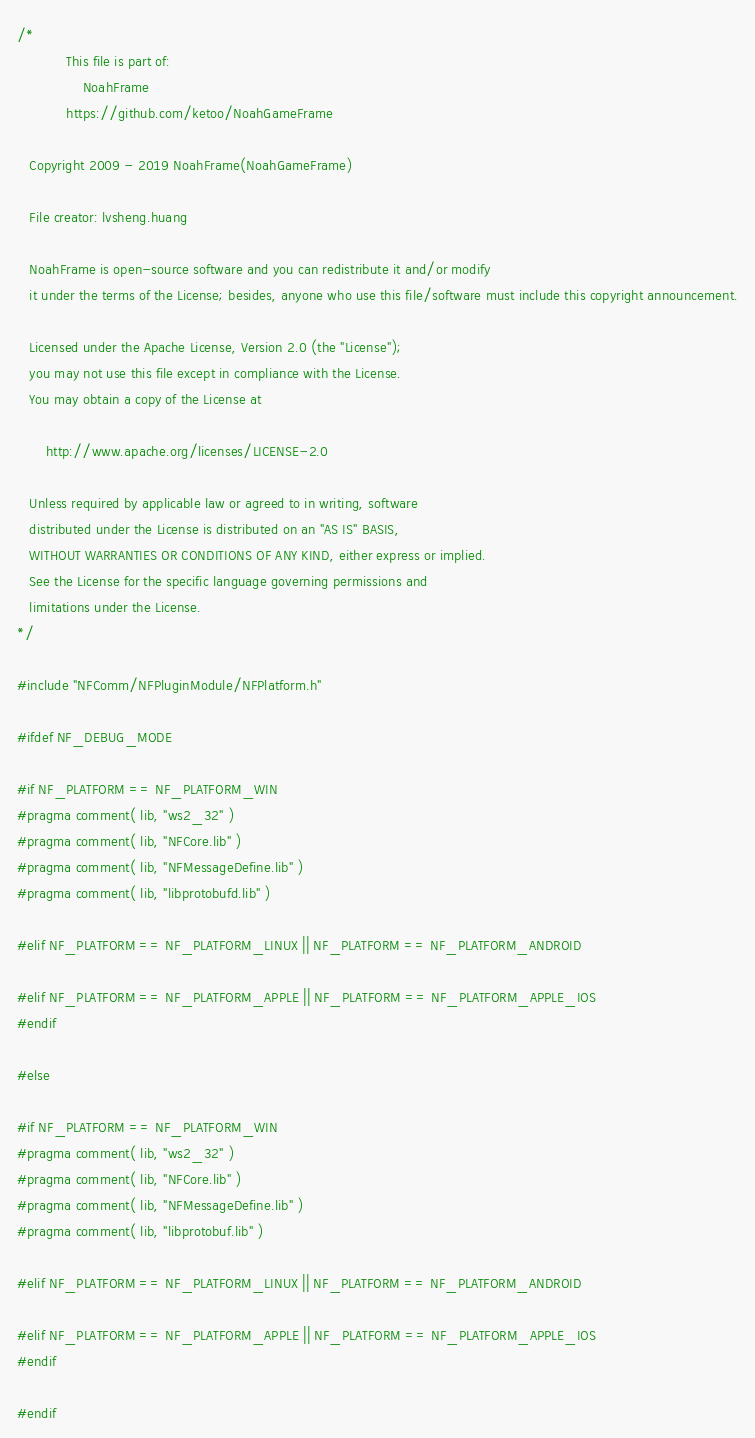<code> <loc_0><loc_0><loc_500><loc_500><_C++_>/*
            This file is part of: 
                NoahFrame
            https://github.com/ketoo/NoahGameFrame

   Copyright 2009 - 2019 NoahFrame(NoahGameFrame)

   File creator: lvsheng.huang
   
   NoahFrame is open-source software and you can redistribute it and/or modify
   it under the terms of the License; besides, anyone who use this file/software must include this copyright announcement.

   Licensed under the Apache License, Version 2.0 (the "License");
   you may not use this file except in compliance with the License.
   You may obtain a copy of the License at

       http://www.apache.org/licenses/LICENSE-2.0

   Unless required by applicable law or agreed to in writing, software
   distributed under the License is distributed on an "AS IS" BASIS,
   WITHOUT WARRANTIES OR CONDITIONS OF ANY KIND, either express or implied.
   See the License for the specific language governing permissions and
   limitations under the License.
*/

#include "NFComm/NFPluginModule/NFPlatform.h"

#ifdef NF_DEBUG_MODE

#if NF_PLATFORM == NF_PLATFORM_WIN
#pragma comment( lib, "ws2_32" )
#pragma comment( lib, "NFCore.lib" )
#pragma comment( lib, "NFMessageDefine.lib" )
#pragma comment( lib, "libprotobufd.lib" )

#elif NF_PLATFORM == NF_PLATFORM_LINUX || NF_PLATFORM == NF_PLATFORM_ANDROID

#elif NF_PLATFORM == NF_PLATFORM_APPLE || NF_PLATFORM == NF_PLATFORM_APPLE_IOS
#endif

#else

#if NF_PLATFORM == NF_PLATFORM_WIN
#pragma comment( lib, "ws2_32" )
#pragma comment( lib, "NFCore.lib" )
#pragma comment( lib, "NFMessageDefine.lib" )
#pragma comment( lib, "libprotobuf.lib" )

#elif NF_PLATFORM == NF_PLATFORM_LINUX || NF_PLATFORM == NF_PLATFORM_ANDROID

#elif NF_PLATFORM == NF_PLATFORM_APPLE || NF_PLATFORM == NF_PLATFORM_APPLE_IOS
#endif

#endif</code> 